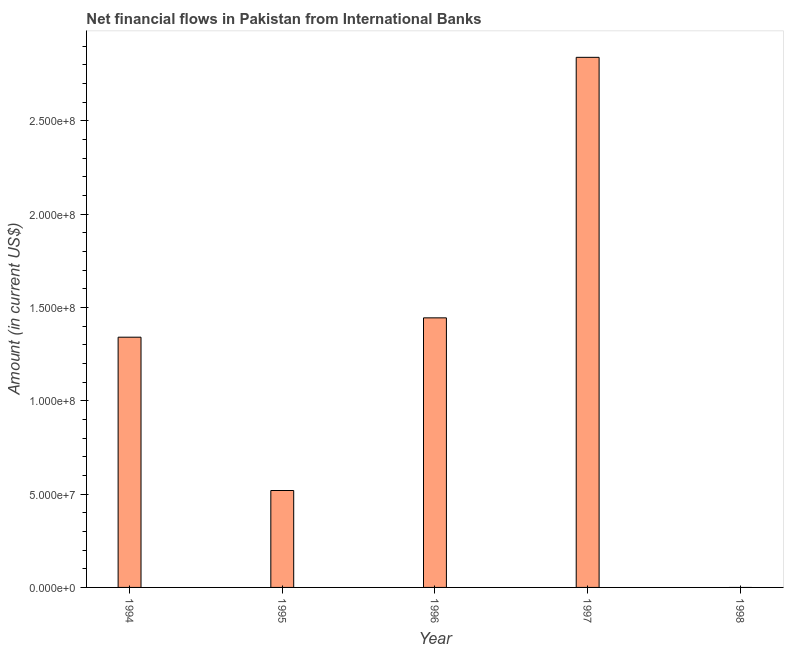What is the title of the graph?
Offer a terse response. Net financial flows in Pakistan from International Banks. What is the label or title of the Y-axis?
Your response must be concise. Amount (in current US$). What is the net financial flows from ibrd in 1995?
Offer a terse response. 5.19e+07. Across all years, what is the maximum net financial flows from ibrd?
Offer a terse response. 2.84e+08. Across all years, what is the minimum net financial flows from ibrd?
Your answer should be very brief. 0. In which year was the net financial flows from ibrd maximum?
Make the answer very short. 1997. What is the sum of the net financial flows from ibrd?
Give a very brief answer. 6.14e+08. What is the difference between the net financial flows from ibrd in 1994 and 1997?
Provide a short and direct response. -1.50e+08. What is the average net financial flows from ibrd per year?
Your answer should be compact. 1.23e+08. What is the median net financial flows from ibrd?
Your answer should be very brief. 1.34e+08. What is the ratio of the net financial flows from ibrd in 1996 to that in 1997?
Offer a very short reply. 0.51. Is the difference between the net financial flows from ibrd in 1996 and 1997 greater than the difference between any two years?
Keep it short and to the point. No. What is the difference between the highest and the second highest net financial flows from ibrd?
Ensure brevity in your answer.  1.40e+08. What is the difference between the highest and the lowest net financial flows from ibrd?
Make the answer very short. 2.84e+08. In how many years, is the net financial flows from ibrd greater than the average net financial flows from ibrd taken over all years?
Your answer should be very brief. 3. What is the difference between two consecutive major ticks on the Y-axis?
Offer a terse response. 5.00e+07. What is the Amount (in current US$) in 1994?
Ensure brevity in your answer.  1.34e+08. What is the Amount (in current US$) of 1995?
Ensure brevity in your answer.  5.19e+07. What is the Amount (in current US$) of 1996?
Your answer should be compact. 1.44e+08. What is the Amount (in current US$) in 1997?
Your response must be concise. 2.84e+08. What is the Amount (in current US$) of 1998?
Ensure brevity in your answer.  0. What is the difference between the Amount (in current US$) in 1994 and 1995?
Offer a terse response. 8.21e+07. What is the difference between the Amount (in current US$) in 1994 and 1996?
Provide a short and direct response. -1.04e+07. What is the difference between the Amount (in current US$) in 1994 and 1997?
Offer a very short reply. -1.50e+08. What is the difference between the Amount (in current US$) in 1995 and 1996?
Make the answer very short. -9.25e+07. What is the difference between the Amount (in current US$) in 1995 and 1997?
Give a very brief answer. -2.32e+08. What is the difference between the Amount (in current US$) in 1996 and 1997?
Your answer should be compact. -1.40e+08. What is the ratio of the Amount (in current US$) in 1994 to that in 1995?
Give a very brief answer. 2.58. What is the ratio of the Amount (in current US$) in 1994 to that in 1996?
Keep it short and to the point. 0.93. What is the ratio of the Amount (in current US$) in 1994 to that in 1997?
Ensure brevity in your answer.  0.47. What is the ratio of the Amount (in current US$) in 1995 to that in 1996?
Your answer should be compact. 0.36. What is the ratio of the Amount (in current US$) in 1995 to that in 1997?
Offer a terse response. 0.18. What is the ratio of the Amount (in current US$) in 1996 to that in 1997?
Offer a very short reply. 0.51. 